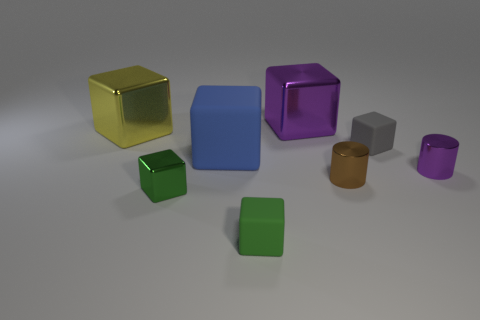Is there anything else that is the same shape as the gray thing?
Give a very brief answer. Yes. There is a matte object that is on the left side of the tiny matte cube in front of the small cube that is behind the small brown thing; what is its color?
Offer a terse response. Blue. Are there fewer green metal cubes that are to the left of the yellow metallic cube than brown things that are behind the big rubber thing?
Ensure brevity in your answer.  No. Does the big blue object have the same shape as the tiny green shiny thing?
Provide a short and direct response. Yes. How many gray rubber cubes have the same size as the brown thing?
Make the answer very short. 1. Are there fewer metallic objects behind the big blue object than big blue shiny cubes?
Your answer should be very brief. No. What is the size of the green object in front of the metallic object that is in front of the brown thing?
Keep it short and to the point. Small. What number of objects are either small green matte spheres or small shiny blocks?
Give a very brief answer. 1. Are there any shiny cubes of the same color as the large rubber object?
Your response must be concise. No. Is the number of yellow objects less than the number of small blue metallic objects?
Your answer should be very brief. No. 